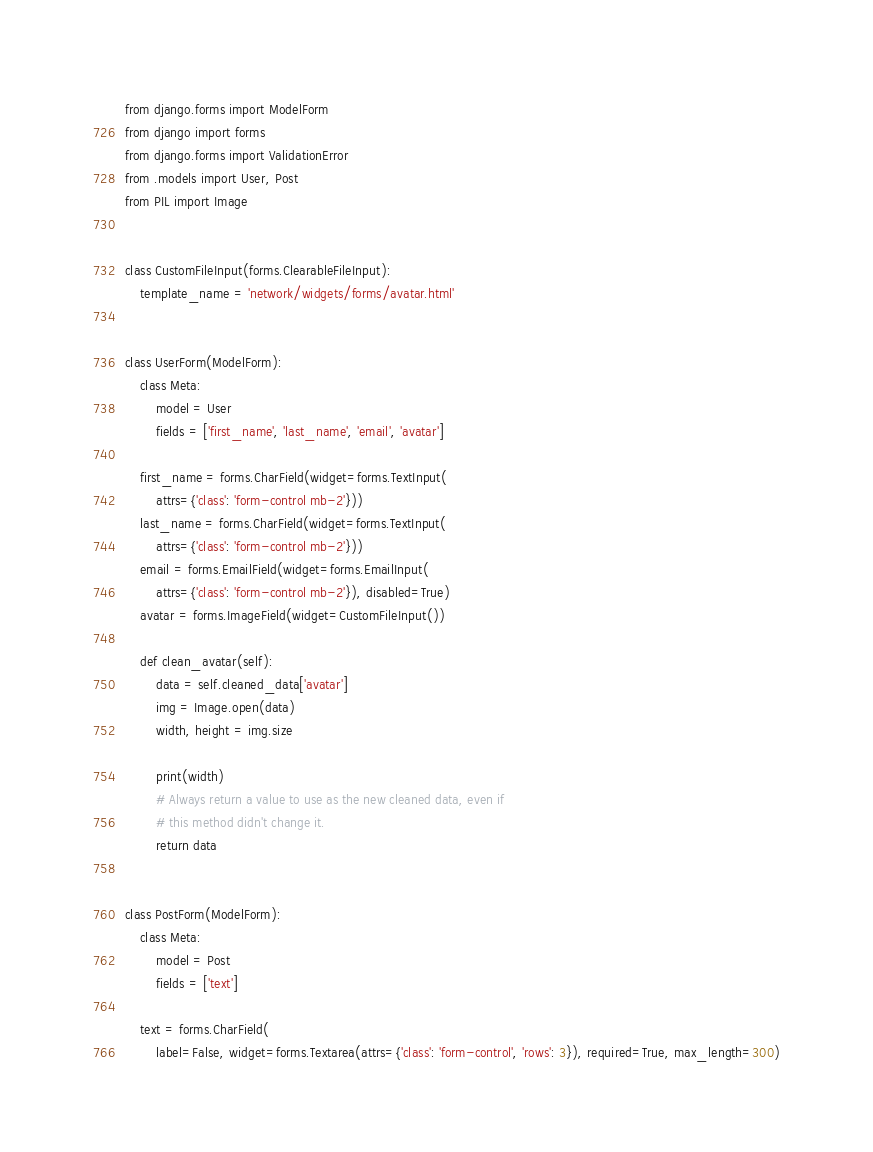<code> <loc_0><loc_0><loc_500><loc_500><_Python_>from django.forms import ModelForm
from django import forms
from django.forms import ValidationError
from .models import User, Post
from PIL import Image


class CustomFileInput(forms.ClearableFileInput):
    template_name = 'network/widgets/forms/avatar.html'


class UserForm(ModelForm):
    class Meta:
        model = User
        fields = ['first_name', 'last_name', 'email', 'avatar']

    first_name = forms.CharField(widget=forms.TextInput(
        attrs={'class': 'form-control mb-2'}))
    last_name = forms.CharField(widget=forms.TextInput(
        attrs={'class': 'form-control mb-2'}))
    email = forms.EmailField(widget=forms.EmailInput(
        attrs={'class': 'form-control mb-2'}), disabled=True)
    avatar = forms.ImageField(widget=CustomFileInput())

    def clean_avatar(self):
        data = self.cleaned_data['avatar']
        img = Image.open(data)
        width, height = img.size

        print(width)
        # Always return a value to use as the new cleaned data, even if
        # this method didn't change it.
        return data


class PostForm(ModelForm):
    class Meta:
        model = Post
        fields = ['text']

    text = forms.CharField(
        label=False, widget=forms.Textarea(attrs={'class': 'form-control', 'rows': 3}), required=True, max_length=300)
</code> 